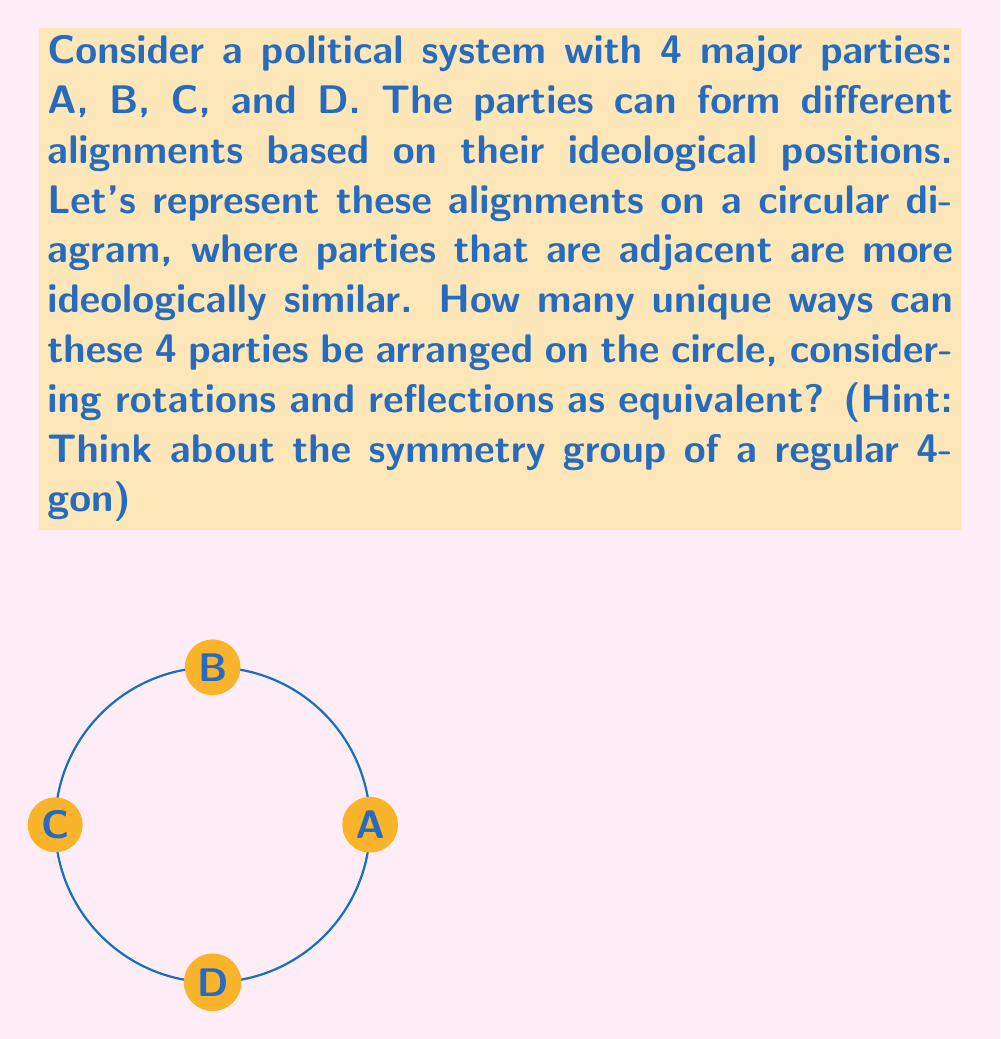Could you help me with this problem? To solve this problem, we need to consider the symmetry group of a regular 4-gon (square), as the parties are arranged in a circular formation with 4 positions.

1) First, let's count the total number of permutations of 4 parties:
   $4! = 4 \times 3 \times 2 \times 1 = 24$

2) However, not all of these permutations are unique when considering rotations and reflections:

   a) Rotational symmetry: A square has 4 rotational symmetries (0°, 90°, 180°, 270°)
   b) Reflectional symmetry: A square has 4 lines of reflection (2 diagonals and 2 midlines)

3) The total number of symmetries in a square is the sum of rotational and reflectional symmetries:
   $4 + 4 = 8$

4) This means that each unique arrangement appears 8 times in our initial count of 24 permutations.

5) To find the number of unique arrangements, we divide the total permutations by the number of symmetries:

   $$\frac{24}{8} = 3$$

This result aligns with the concept of the dihedral group $D_4$, which is the symmetry group of a regular 4-gon. The order of $D_4$ is 8, which represents the 8 symmetries we counted.

In the context of political science, this result suggests that despite 24 possible orderings of 4 parties, there are only 3 fundamentally different alignments when considering ideological proximity as represented by adjacency on the circle.
Answer: 3 